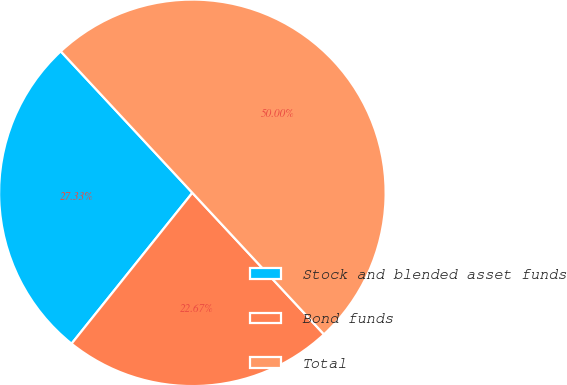<chart> <loc_0><loc_0><loc_500><loc_500><pie_chart><fcel>Stock and blended asset funds<fcel>Bond funds<fcel>Total<nl><fcel>27.33%<fcel>22.67%<fcel>50.0%<nl></chart> 